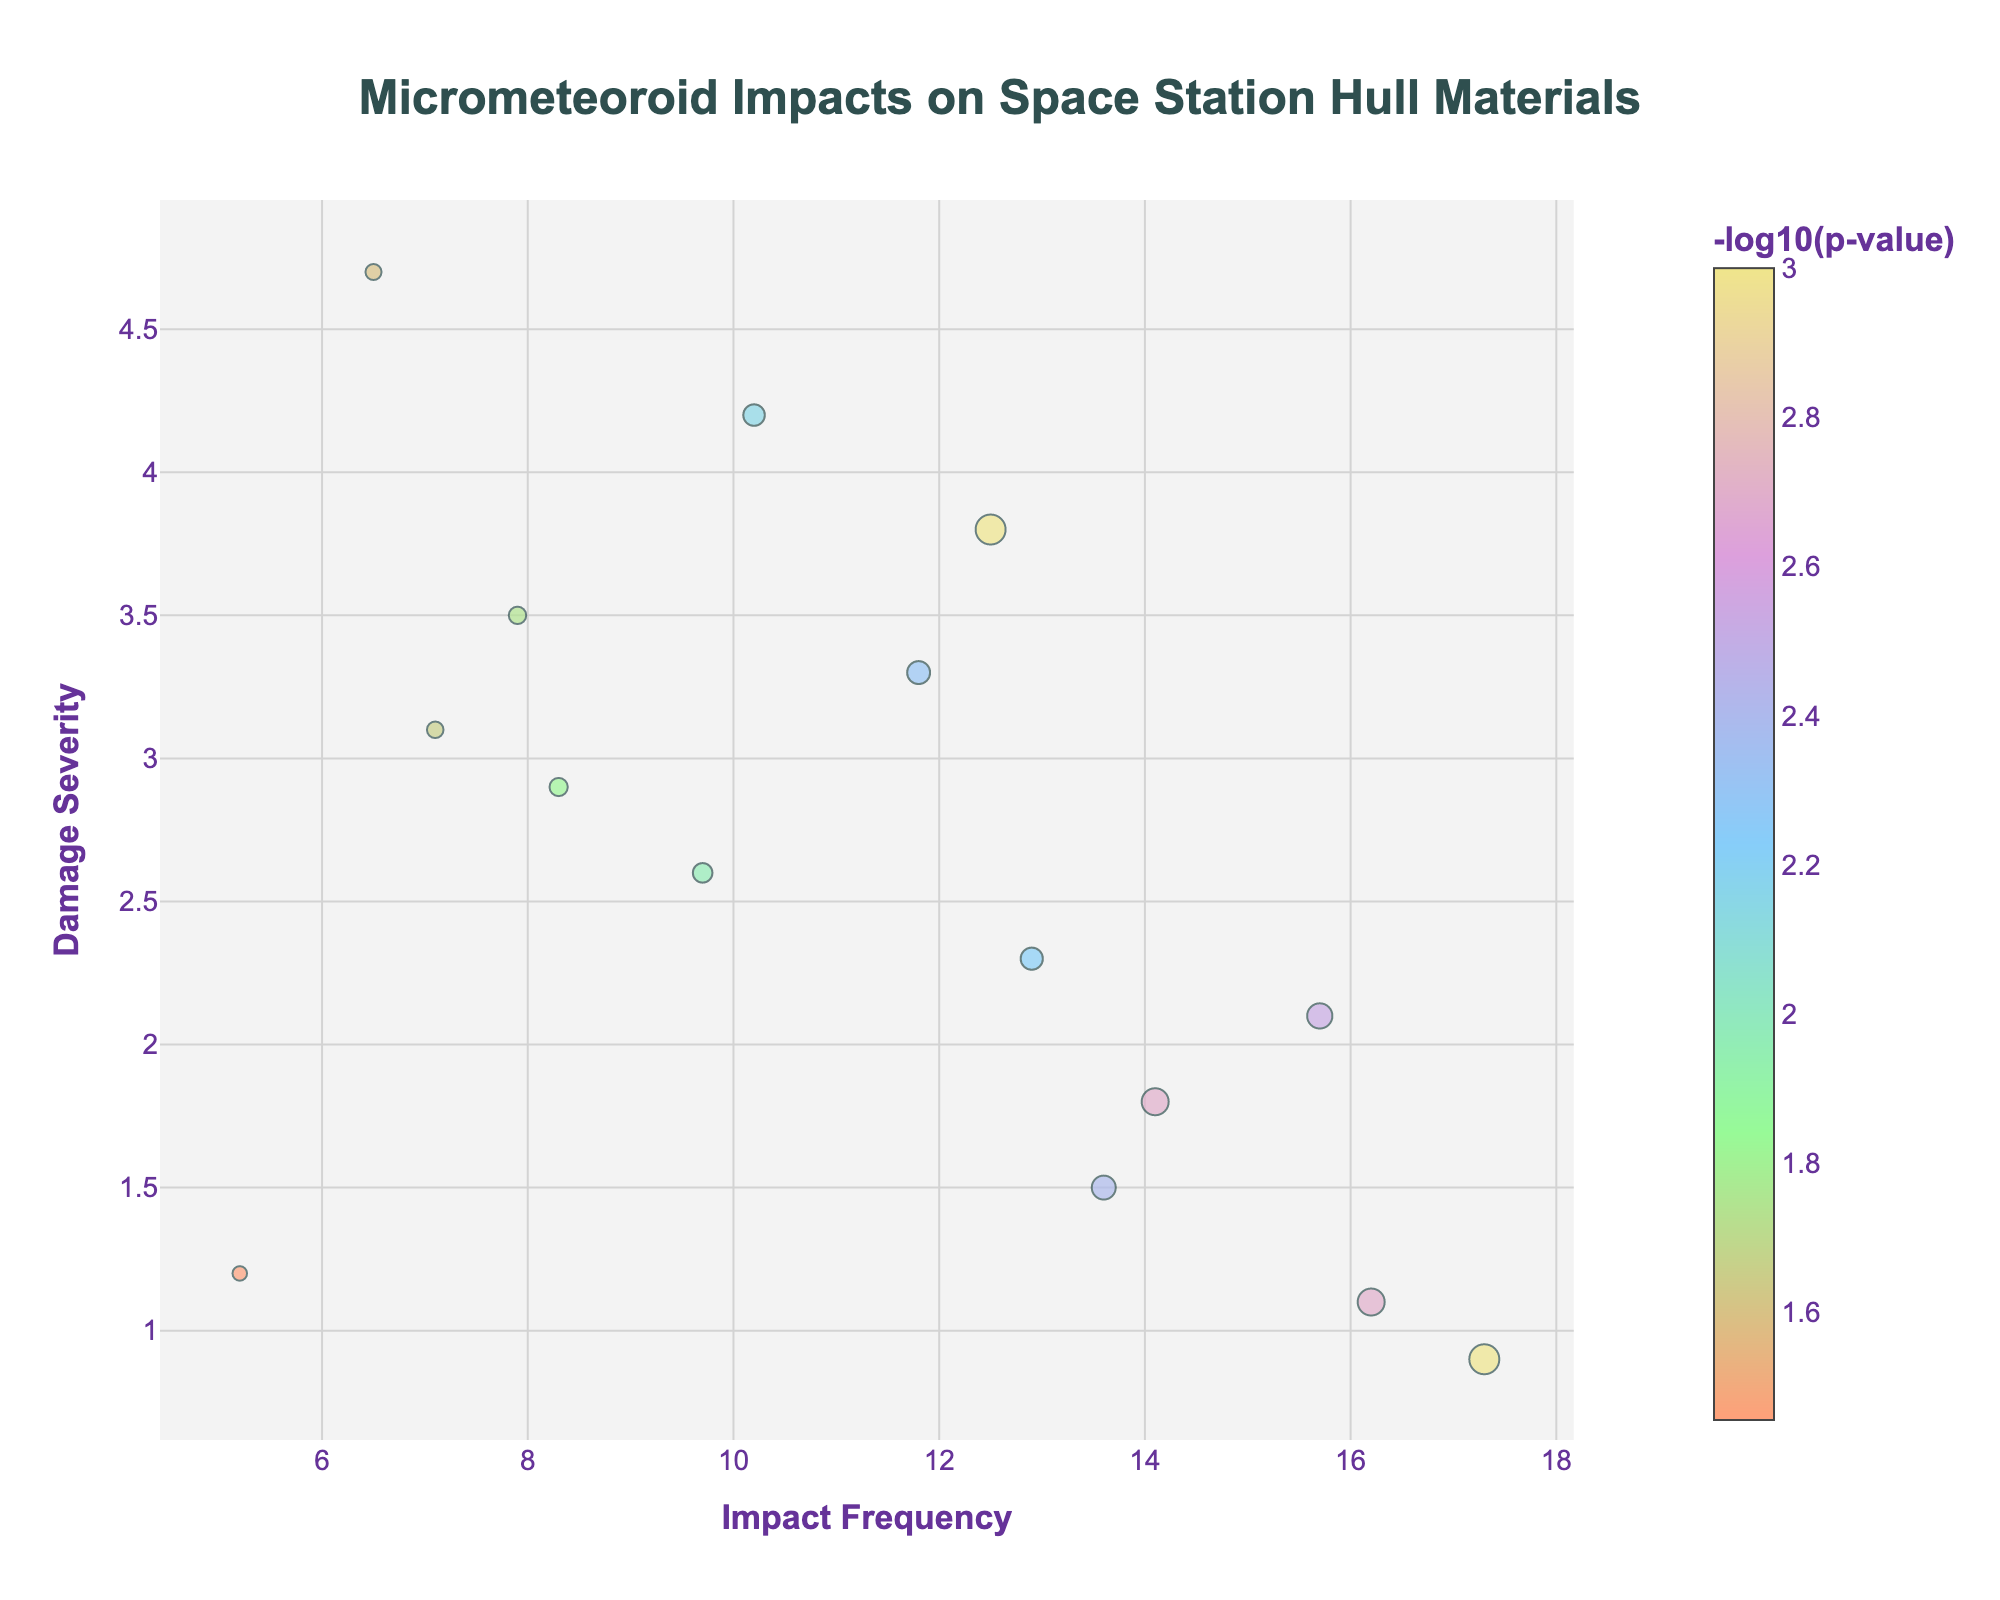How many materials are shown in the volcano plot? Firstly, identify the total number of data points on the plot, which corresponds to the number of materials. Each marker represents one material. In the dataset provided, there are 15 materials.
Answer: 15 Which material has the highest impact frequency? To find the material with the highest impact frequency, look for the marker farthest to the right on the horizontal axis labeled "Impact Frequency." According to the dataset, the highest impact frequency is 17.3, which corresponds to Multi-Layer Insulation (MLI).
Answer: Multi-Layer Insulation (MLI) Which material exhibits the greatest severity of damage? Look for the marker positioned highest on the vertical axis labeled "Damage Severity." In the dataset, the highest damage severity, 4.7, corresponds to Beryllium.
Answer: Beryllium Which material has the lowest p-value? The color intensity and size of the marker correspond to the -log10(p-value). The lowest p-value will have the highest -log10(p-value). From the data provided, the lowest p-value is 0.001, shared by Aluminum Alloy 2219 and Multi-Layer Insulation (MLI). Both these materials will have the largest and most intense markers.
Answer: Aluminum Alloy 2219, Multi-Layer Insulation (MLI) Among the materials with impact frequencies above 10, which one has the lowest damage severity? Filter the materials with an impact frequency greater than 10 (Aluminum Alloy 2219, Kevlar-Epoxy Composite, Aluminum-Lithium Alloy 2195, Nextel Ceramic Fabric, Multi-Layer Insulation (MLI), and Vectran Fiber Composite). Out of these, the one with the lowest damage severity is Multi-Layer Insulation (MLI) with a damage severity of 0.9.
Answer: Multi-Layer Insulation (MLI) Which material has both high impact frequency and high damage severity? Identify the materials that have high values on both axes. In the plot, look for markers positioned towards the top-right corner. Aluminum Alloy 2219 has a high impact frequency of 12.5 and a relatively high damage severity of 3.8.
Answer: Aluminum Alloy 2219 What is the relationship between impact frequency and -log10(p-value)? Examining the data points for patterns, observe whether higher impact frequencies are associated with higher -log10(p-value). Commonly, higher -log10(p-value) indicates statistical significance. In this plot, no clear trend is visible; some high-frequency impacts have high -log10(p-value), and some do not.
Answer: No clear trend How does the damage severity of the Whipple Shield compare to that of Carbon Fiber Reinforced Polymer? Locate the markers for Whipple Shield (Damage Severity = 1.2) and Carbon Fiber Reinforced Polymer (Damage Severity = 1.8) and compare their vertical positions. Whipple Shield has lower damage severity than Carbon Fiber Reinforced Polymer.
Answer: Whipple Shield has lower damage severity Between Aluminum-Lithium Alloy 2195 and Boron Nitride Nanotube Reinforced Aluminum, which has a lower p-value but higher damage severity? Identify the -log10(p-value) and damage severity for both materials. Aluminum-Lithium Alloy 2195 has p-value = 0.005 with damage severity = 3.3. Boron Nitride Nanotube Reinforced Aluminum has p-value = 0.022 with damage severity = 3.1. Therefore, Aluminum-Lithium Alloy 2195 has a lower p-value and higher damage severity compared to Boron Nitride Nanotube Reinforced Aluminum.
Answer: Aluminum-Lithium Alloy 2195 